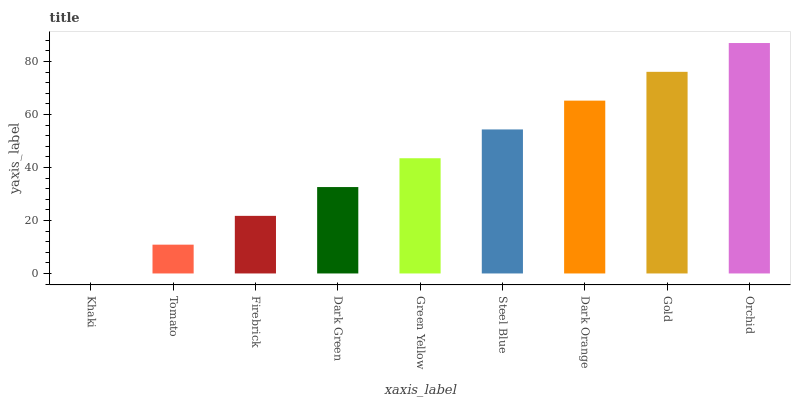Is Khaki the minimum?
Answer yes or no. Yes. Is Orchid the maximum?
Answer yes or no. Yes. Is Tomato the minimum?
Answer yes or no. No. Is Tomato the maximum?
Answer yes or no. No. Is Tomato greater than Khaki?
Answer yes or no. Yes. Is Khaki less than Tomato?
Answer yes or no. Yes. Is Khaki greater than Tomato?
Answer yes or no. No. Is Tomato less than Khaki?
Answer yes or no. No. Is Green Yellow the high median?
Answer yes or no. Yes. Is Green Yellow the low median?
Answer yes or no. Yes. Is Khaki the high median?
Answer yes or no. No. Is Firebrick the low median?
Answer yes or no. No. 